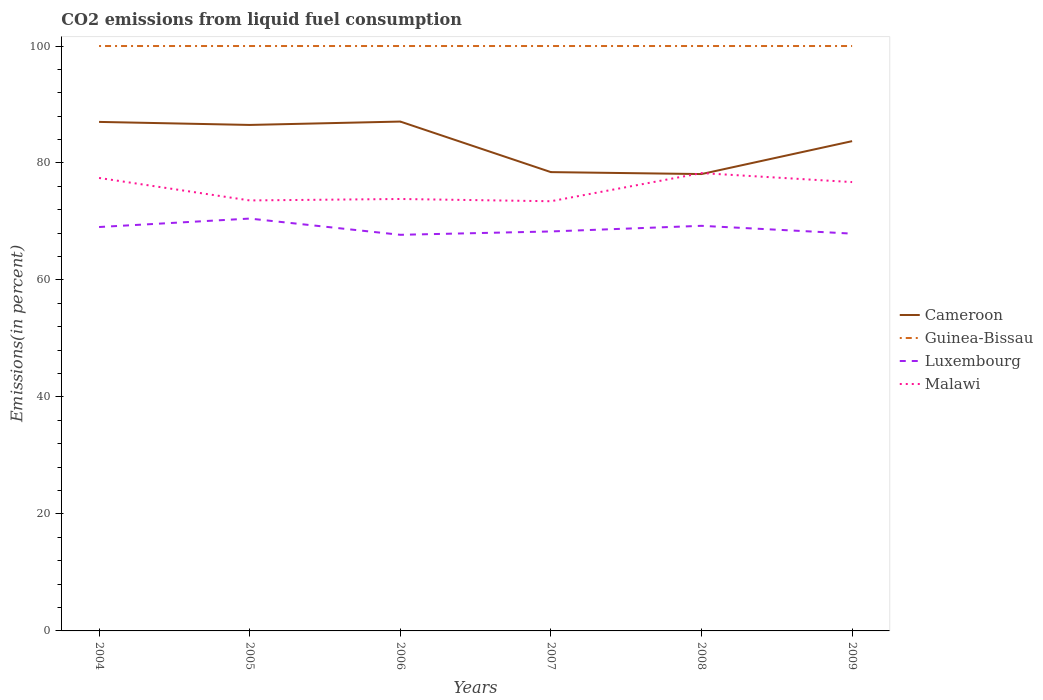Does the line corresponding to Luxembourg intersect with the line corresponding to Guinea-Bissau?
Make the answer very short. No. Across all years, what is the maximum total CO2 emitted in Malawi?
Ensure brevity in your answer.  73.46. In which year was the total CO2 emitted in Guinea-Bissau maximum?
Offer a terse response. 2004. What is the total total CO2 emitted in Guinea-Bissau in the graph?
Your answer should be very brief. 0. What is the difference between the highest and the second highest total CO2 emitted in Malawi?
Keep it short and to the point. 4.81. Is the total CO2 emitted in Guinea-Bissau strictly greater than the total CO2 emitted in Luxembourg over the years?
Provide a succinct answer. No. What is the difference between two consecutive major ticks on the Y-axis?
Give a very brief answer. 20. Are the values on the major ticks of Y-axis written in scientific E-notation?
Give a very brief answer. No. How many legend labels are there?
Your answer should be compact. 4. What is the title of the graph?
Provide a succinct answer. CO2 emissions from liquid fuel consumption. Does "Timor-Leste" appear as one of the legend labels in the graph?
Give a very brief answer. No. What is the label or title of the X-axis?
Your response must be concise. Years. What is the label or title of the Y-axis?
Ensure brevity in your answer.  Emissions(in percent). What is the Emissions(in percent) of Cameroon in 2004?
Your answer should be very brief. 87.03. What is the Emissions(in percent) of Guinea-Bissau in 2004?
Your answer should be compact. 100. What is the Emissions(in percent) of Luxembourg in 2004?
Provide a succinct answer. 69.05. What is the Emissions(in percent) in Malawi in 2004?
Provide a succinct answer. 77.44. What is the Emissions(in percent) of Cameroon in 2005?
Provide a succinct answer. 86.51. What is the Emissions(in percent) in Luxembourg in 2005?
Offer a terse response. 70.5. What is the Emissions(in percent) of Malawi in 2005?
Offer a very short reply. 73.6. What is the Emissions(in percent) in Cameroon in 2006?
Your response must be concise. 87.08. What is the Emissions(in percent) of Guinea-Bissau in 2006?
Your response must be concise. 100. What is the Emissions(in percent) of Luxembourg in 2006?
Offer a terse response. 67.72. What is the Emissions(in percent) of Malawi in 2006?
Provide a succinct answer. 73.85. What is the Emissions(in percent) of Cameroon in 2007?
Offer a very short reply. 78.44. What is the Emissions(in percent) in Luxembourg in 2007?
Offer a very short reply. 68.3. What is the Emissions(in percent) of Malawi in 2007?
Your answer should be compact. 73.46. What is the Emissions(in percent) of Cameroon in 2008?
Your answer should be compact. 78.11. What is the Emissions(in percent) of Guinea-Bissau in 2008?
Offer a very short reply. 100. What is the Emissions(in percent) of Luxembourg in 2008?
Give a very brief answer. 69.26. What is the Emissions(in percent) of Malawi in 2008?
Provide a short and direct response. 78.27. What is the Emissions(in percent) of Cameroon in 2009?
Your answer should be compact. 83.74. What is the Emissions(in percent) in Luxembourg in 2009?
Ensure brevity in your answer.  67.93. What is the Emissions(in percent) in Malawi in 2009?
Ensure brevity in your answer.  76.74. Across all years, what is the maximum Emissions(in percent) of Cameroon?
Offer a very short reply. 87.08. Across all years, what is the maximum Emissions(in percent) of Guinea-Bissau?
Make the answer very short. 100. Across all years, what is the maximum Emissions(in percent) of Luxembourg?
Provide a short and direct response. 70.5. Across all years, what is the maximum Emissions(in percent) in Malawi?
Make the answer very short. 78.27. Across all years, what is the minimum Emissions(in percent) of Cameroon?
Your answer should be very brief. 78.11. Across all years, what is the minimum Emissions(in percent) in Guinea-Bissau?
Provide a short and direct response. 100. Across all years, what is the minimum Emissions(in percent) of Luxembourg?
Give a very brief answer. 67.72. Across all years, what is the minimum Emissions(in percent) of Malawi?
Your response must be concise. 73.46. What is the total Emissions(in percent) in Cameroon in the graph?
Ensure brevity in your answer.  500.9. What is the total Emissions(in percent) of Guinea-Bissau in the graph?
Keep it short and to the point. 600. What is the total Emissions(in percent) of Luxembourg in the graph?
Provide a short and direct response. 412.75. What is the total Emissions(in percent) in Malawi in the graph?
Offer a terse response. 453.36. What is the difference between the Emissions(in percent) in Cameroon in 2004 and that in 2005?
Give a very brief answer. 0.52. What is the difference between the Emissions(in percent) in Luxembourg in 2004 and that in 2005?
Provide a succinct answer. -1.45. What is the difference between the Emissions(in percent) in Malawi in 2004 and that in 2005?
Offer a very short reply. 3.84. What is the difference between the Emissions(in percent) in Cameroon in 2004 and that in 2006?
Offer a terse response. -0.06. What is the difference between the Emissions(in percent) of Guinea-Bissau in 2004 and that in 2006?
Give a very brief answer. 0. What is the difference between the Emissions(in percent) of Luxembourg in 2004 and that in 2006?
Make the answer very short. 1.33. What is the difference between the Emissions(in percent) in Malawi in 2004 and that in 2006?
Keep it short and to the point. 3.6. What is the difference between the Emissions(in percent) of Cameroon in 2004 and that in 2007?
Offer a terse response. 8.58. What is the difference between the Emissions(in percent) of Luxembourg in 2004 and that in 2007?
Keep it short and to the point. 0.76. What is the difference between the Emissions(in percent) of Malawi in 2004 and that in 2007?
Ensure brevity in your answer.  3.98. What is the difference between the Emissions(in percent) in Cameroon in 2004 and that in 2008?
Your response must be concise. 8.92. What is the difference between the Emissions(in percent) of Guinea-Bissau in 2004 and that in 2008?
Offer a very short reply. 0. What is the difference between the Emissions(in percent) of Luxembourg in 2004 and that in 2008?
Your answer should be compact. -0.21. What is the difference between the Emissions(in percent) in Malawi in 2004 and that in 2008?
Your answer should be very brief. -0.83. What is the difference between the Emissions(in percent) of Cameroon in 2004 and that in 2009?
Keep it short and to the point. 3.29. What is the difference between the Emissions(in percent) of Luxembourg in 2004 and that in 2009?
Your answer should be very brief. 1.13. What is the difference between the Emissions(in percent) of Malawi in 2004 and that in 2009?
Give a very brief answer. 0.71. What is the difference between the Emissions(in percent) in Cameroon in 2005 and that in 2006?
Offer a very short reply. -0.58. What is the difference between the Emissions(in percent) of Luxembourg in 2005 and that in 2006?
Your response must be concise. 2.78. What is the difference between the Emissions(in percent) of Malawi in 2005 and that in 2006?
Make the answer very short. -0.25. What is the difference between the Emissions(in percent) in Cameroon in 2005 and that in 2007?
Keep it short and to the point. 8.07. What is the difference between the Emissions(in percent) in Luxembourg in 2005 and that in 2007?
Give a very brief answer. 2.2. What is the difference between the Emissions(in percent) in Malawi in 2005 and that in 2007?
Your answer should be very brief. 0.14. What is the difference between the Emissions(in percent) in Cameroon in 2005 and that in 2008?
Provide a short and direct response. 8.4. What is the difference between the Emissions(in percent) in Guinea-Bissau in 2005 and that in 2008?
Keep it short and to the point. 0. What is the difference between the Emissions(in percent) in Luxembourg in 2005 and that in 2008?
Offer a very short reply. 1.24. What is the difference between the Emissions(in percent) in Malawi in 2005 and that in 2008?
Your response must be concise. -4.67. What is the difference between the Emissions(in percent) in Cameroon in 2005 and that in 2009?
Your response must be concise. 2.77. What is the difference between the Emissions(in percent) in Luxembourg in 2005 and that in 2009?
Your answer should be very brief. 2.57. What is the difference between the Emissions(in percent) in Malawi in 2005 and that in 2009?
Your response must be concise. -3.14. What is the difference between the Emissions(in percent) in Cameroon in 2006 and that in 2007?
Offer a very short reply. 8.64. What is the difference between the Emissions(in percent) of Guinea-Bissau in 2006 and that in 2007?
Offer a very short reply. 0. What is the difference between the Emissions(in percent) in Luxembourg in 2006 and that in 2007?
Your response must be concise. -0.57. What is the difference between the Emissions(in percent) in Malawi in 2006 and that in 2007?
Give a very brief answer. 0.38. What is the difference between the Emissions(in percent) in Cameroon in 2006 and that in 2008?
Offer a terse response. 8.98. What is the difference between the Emissions(in percent) of Luxembourg in 2006 and that in 2008?
Provide a short and direct response. -1.54. What is the difference between the Emissions(in percent) of Malawi in 2006 and that in 2008?
Keep it short and to the point. -4.43. What is the difference between the Emissions(in percent) of Cameroon in 2006 and that in 2009?
Make the answer very short. 3.35. What is the difference between the Emissions(in percent) of Guinea-Bissau in 2006 and that in 2009?
Your response must be concise. 0. What is the difference between the Emissions(in percent) of Luxembourg in 2006 and that in 2009?
Ensure brevity in your answer.  -0.2. What is the difference between the Emissions(in percent) in Malawi in 2006 and that in 2009?
Your response must be concise. -2.89. What is the difference between the Emissions(in percent) of Cameroon in 2007 and that in 2008?
Keep it short and to the point. 0.33. What is the difference between the Emissions(in percent) in Guinea-Bissau in 2007 and that in 2008?
Offer a terse response. 0. What is the difference between the Emissions(in percent) in Luxembourg in 2007 and that in 2008?
Give a very brief answer. -0.96. What is the difference between the Emissions(in percent) in Malawi in 2007 and that in 2008?
Offer a terse response. -4.81. What is the difference between the Emissions(in percent) in Cameroon in 2007 and that in 2009?
Offer a terse response. -5.29. What is the difference between the Emissions(in percent) in Guinea-Bissau in 2007 and that in 2009?
Your answer should be very brief. 0. What is the difference between the Emissions(in percent) of Luxembourg in 2007 and that in 2009?
Offer a terse response. 0.37. What is the difference between the Emissions(in percent) of Malawi in 2007 and that in 2009?
Offer a very short reply. -3.27. What is the difference between the Emissions(in percent) in Cameroon in 2008 and that in 2009?
Provide a succinct answer. -5.63. What is the difference between the Emissions(in percent) in Luxembourg in 2008 and that in 2009?
Offer a very short reply. 1.33. What is the difference between the Emissions(in percent) in Malawi in 2008 and that in 2009?
Your answer should be compact. 1.54. What is the difference between the Emissions(in percent) of Cameroon in 2004 and the Emissions(in percent) of Guinea-Bissau in 2005?
Make the answer very short. -12.97. What is the difference between the Emissions(in percent) in Cameroon in 2004 and the Emissions(in percent) in Luxembourg in 2005?
Your answer should be very brief. 16.53. What is the difference between the Emissions(in percent) of Cameroon in 2004 and the Emissions(in percent) of Malawi in 2005?
Make the answer very short. 13.43. What is the difference between the Emissions(in percent) in Guinea-Bissau in 2004 and the Emissions(in percent) in Luxembourg in 2005?
Keep it short and to the point. 29.5. What is the difference between the Emissions(in percent) in Guinea-Bissau in 2004 and the Emissions(in percent) in Malawi in 2005?
Your response must be concise. 26.4. What is the difference between the Emissions(in percent) in Luxembourg in 2004 and the Emissions(in percent) in Malawi in 2005?
Offer a very short reply. -4.55. What is the difference between the Emissions(in percent) of Cameroon in 2004 and the Emissions(in percent) of Guinea-Bissau in 2006?
Offer a terse response. -12.97. What is the difference between the Emissions(in percent) of Cameroon in 2004 and the Emissions(in percent) of Luxembourg in 2006?
Provide a short and direct response. 19.3. What is the difference between the Emissions(in percent) of Cameroon in 2004 and the Emissions(in percent) of Malawi in 2006?
Provide a short and direct response. 13.18. What is the difference between the Emissions(in percent) in Guinea-Bissau in 2004 and the Emissions(in percent) in Luxembourg in 2006?
Offer a terse response. 32.28. What is the difference between the Emissions(in percent) in Guinea-Bissau in 2004 and the Emissions(in percent) in Malawi in 2006?
Provide a short and direct response. 26.15. What is the difference between the Emissions(in percent) of Luxembourg in 2004 and the Emissions(in percent) of Malawi in 2006?
Give a very brief answer. -4.79. What is the difference between the Emissions(in percent) in Cameroon in 2004 and the Emissions(in percent) in Guinea-Bissau in 2007?
Provide a succinct answer. -12.97. What is the difference between the Emissions(in percent) in Cameroon in 2004 and the Emissions(in percent) in Luxembourg in 2007?
Your answer should be very brief. 18.73. What is the difference between the Emissions(in percent) in Cameroon in 2004 and the Emissions(in percent) in Malawi in 2007?
Make the answer very short. 13.56. What is the difference between the Emissions(in percent) in Guinea-Bissau in 2004 and the Emissions(in percent) in Luxembourg in 2007?
Offer a very short reply. 31.7. What is the difference between the Emissions(in percent) of Guinea-Bissau in 2004 and the Emissions(in percent) of Malawi in 2007?
Offer a very short reply. 26.54. What is the difference between the Emissions(in percent) in Luxembourg in 2004 and the Emissions(in percent) in Malawi in 2007?
Keep it short and to the point. -4.41. What is the difference between the Emissions(in percent) of Cameroon in 2004 and the Emissions(in percent) of Guinea-Bissau in 2008?
Give a very brief answer. -12.97. What is the difference between the Emissions(in percent) in Cameroon in 2004 and the Emissions(in percent) in Luxembourg in 2008?
Give a very brief answer. 17.77. What is the difference between the Emissions(in percent) of Cameroon in 2004 and the Emissions(in percent) of Malawi in 2008?
Ensure brevity in your answer.  8.75. What is the difference between the Emissions(in percent) in Guinea-Bissau in 2004 and the Emissions(in percent) in Luxembourg in 2008?
Your answer should be compact. 30.74. What is the difference between the Emissions(in percent) in Guinea-Bissau in 2004 and the Emissions(in percent) in Malawi in 2008?
Give a very brief answer. 21.73. What is the difference between the Emissions(in percent) in Luxembourg in 2004 and the Emissions(in percent) in Malawi in 2008?
Make the answer very short. -9.22. What is the difference between the Emissions(in percent) in Cameroon in 2004 and the Emissions(in percent) in Guinea-Bissau in 2009?
Offer a very short reply. -12.97. What is the difference between the Emissions(in percent) in Cameroon in 2004 and the Emissions(in percent) in Luxembourg in 2009?
Offer a very short reply. 19.1. What is the difference between the Emissions(in percent) of Cameroon in 2004 and the Emissions(in percent) of Malawi in 2009?
Your response must be concise. 10.29. What is the difference between the Emissions(in percent) in Guinea-Bissau in 2004 and the Emissions(in percent) in Luxembourg in 2009?
Provide a short and direct response. 32.07. What is the difference between the Emissions(in percent) of Guinea-Bissau in 2004 and the Emissions(in percent) of Malawi in 2009?
Make the answer very short. 23.26. What is the difference between the Emissions(in percent) of Luxembourg in 2004 and the Emissions(in percent) of Malawi in 2009?
Give a very brief answer. -7.68. What is the difference between the Emissions(in percent) in Cameroon in 2005 and the Emissions(in percent) in Guinea-Bissau in 2006?
Your answer should be very brief. -13.49. What is the difference between the Emissions(in percent) in Cameroon in 2005 and the Emissions(in percent) in Luxembourg in 2006?
Make the answer very short. 18.79. What is the difference between the Emissions(in percent) in Cameroon in 2005 and the Emissions(in percent) in Malawi in 2006?
Give a very brief answer. 12.66. What is the difference between the Emissions(in percent) in Guinea-Bissau in 2005 and the Emissions(in percent) in Luxembourg in 2006?
Provide a short and direct response. 32.28. What is the difference between the Emissions(in percent) of Guinea-Bissau in 2005 and the Emissions(in percent) of Malawi in 2006?
Your answer should be compact. 26.15. What is the difference between the Emissions(in percent) in Luxembourg in 2005 and the Emissions(in percent) in Malawi in 2006?
Give a very brief answer. -3.35. What is the difference between the Emissions(in percent) in Cameroon in 2005 and the Emissions(in percent) in Guinea-Bissau in 2007?
Give a very brief answer. -13.49. What is the difference between the Emissions(in percent) in Cameroon in 2005 and the Emissions(in percent) in Luxembourg in 2007?
Provide a short and direct response. 18.21. What is the difference between the Emissions(in percent) in Cameroon in 2005 and the Emissions(in percent) in Malawi in 2007?
Provide a succinct answer. 13.05. What is the difference between the Emissions(in percent) of Guinea-Bissau in 2005 and the Emissions(in percent) of Luxembourg in 2007?
Give a very brief answer. 31.7. What is the difference between the Emissions(in percent) in Guinea-Bissau in 2005 and the Emissions(in percent) in Malawi in 2007?
Your answer should be very brief. 26.54. What is the difference between the Emissions(in percent) in Luxembourg in 2005 and the Emissions(in percent) in Malawi in 2007?
Provide a succinct answer. -2.96. What is the difference between the Emissions(in percent) of Cameroon in 2005 and the Emissions(in percent) of Guinea-Bissau in 2008?
Your answer should be very brief. -13.49. What is the difference between the Emissions(in percent) of Cameroon in 2005 and the Emissions(in percent) of Luxembourg in 2008?
Ensure brevity in your answer.  17.25. What is the difference between the Emissions(in percent) of Cameroon in 2005 and the Emissions(in percent) of Malawi in 2008?
Offer a very short reply. 8.23. What is the difference between the Emissions(in percent) of Guinea-Bissau in 2005 and the Emissions(in percent) of Luxembourg in 2008?
Provide a short and direct response. 30.74. What is the difference between the Emissions(in percent) of Guinea-Bissau in 2005 and the Emissions(in percent) of Malawi in 2008?
Give a very brief answer. 21.73. What is the difference between the Emissions(in percent) in Luxembourg in 2005 and the Emissions(in percent) in Malawi in 2008?
Make the answer very short. -7.78. What is the difference between the Emissions(in percent) of Cameroon in 2005 and the Emissions(in percent) of Guinea-Bissau in 2009?
Your answer should be compact. -13.49. What is the difference between the Emissions(in percent) of Cameroon in 2005 and the Emissions(in percent) of Luxembourg in 2009?
Keep it short and to the point. 18.58. What is the difference between the Emissions(in percent) of Cameroon in 2005 and the Emissions(in percent) of Malawi in 2009?
Keep it short and to the point. 9.77. What is the difference between the Emissions(in percent) in Guinea-Bissau in 2005 and the Emissions(in percent) in Luxembourg in 2009?
Your answer should be very brief. 32.07. What is the difference between the Emissions(in percent) of Guinea-Bissau in 2005 and the Emissions(in percent) of Malawi in 2009?
Offer a very short reply. 23.26. What is the difference between the Emissions(in percent) in Luxembourg in 2005 and the Emissions(in percent) in Malawi in 2009?
Your answer should be very brief. -6.24. What is the difference between the Emissions(in percent) in Cameroon in 2006 and the Emissions(in percent) in Guinea-Bissau in 2007?
Your answer should be compact. -12.92. What is the difference between the Emissions(in percent) in Cameroon in 2006 and the Emissions(in percent) in Luxembourg in 2007?
Your answer should be very brief. 18.79. What is the difference between the Emissions(in percent) in Cameroon in 2006 and the Emissions(in percent) in Malawi in 2007?
Offer a terse response. 13.62. What is the difference between the Emissions(in percent) in Guinea-Bissau in 2006 and the Emissions(in percent) in Luxembourg in 2007?
Make the answer very short. 31.7. What is the difference between the Emissions(in percent) in Guinea-Bissau in 2006 and the Emissions(in percent) in Malawi in 2007?
Offer a terse response. 26.54. What is the difference between the Emissions(in percent) of Luxembourg in 2006 and the Emissions(in percent) of Malawi in 2007?
Offer a terse response. -5.74. What is the difference between the Emissions(in percent) in Cameroon in 2006 and the Emissions(in percent) in Guinea-Bissau in 2008?
Provide a short and direct response. -12.92. What is the difference between the Emissions(in percent) of Cameroon in 2006 and the Emissions(in percent) of Luxembourg in 2008?
Your response must be concise. 17.83. What is the difference between the Emissions(in percent) in Cameroon in 2006 and the Emissions(in percent) in Malawi in 2008?
Your response must be concise. 8.81. What is the difference between the Emissions(in percent) of Guinea-Bissau in 2006 and the Emissions(in percent) of Luxembourg in 2008?
Provide a short and direct response. 30.74. What is the difference between the Emissions(in percent) in Guinea-Bissau in 2006 and the Emissions(in percent) in Malawi in 2008?
Offer a terse response. 21.73. What is the difference between the Emissions(in percent) of Luxembourg in 2006 and the Emissions(in percent) of Malawi in 2008?
Provide a succinct answer. -10.55. What is the difference between the Emissions(in percent) in Cameroon in 2006 and the Emissions(in percent) in Guinea-Bissau in 2009?
Offer a terse response. -12.92. What is the difference between the Emissions(in percent) of Cameroon in 2006 and the Emissions(in percent) of Luxembourg in 2009?
Provide a short and direct response. 19.16. What is the difference between the Emissions(in percent) in Cameroon in 2006 and the Emissions(in percent) in Malawi in 2009?
Give a very brief answer. 10.35. What is the difference between the Emissions(in percent) in Guinea-Bissau in 2006 and the Emissions(in percent) in Luxembourg in 2009?
Ensure brevity in your answer.  32.07. What is the difference between the Emissions(in percent) of Guinea-Bissau in 2006 and the Emissions(in percent) of Malawi in 2009?
Provide a succinct answer. 23.26. What is the difference between the Emissions(in percent) in Luxembourg in 2006 and the Emissions(in percent) in Malawi in 2009?
Give a very brief answer. -9.01. What is the difference between the Emissions(in percent) of Cameroon in 2007 and the Emissions(in percent) of Guinea-Bissau in 2008?
Offer a terse response. -21.56. What is the difference between the Emissions(in percent) of Cameroon in 2007 and the Emissions(in percent) of Luxembourg in 2008?
Provide a succinct answer. 9.18. What is the difference between the Emissions(in percent) in Cameroon in 2007 and the Emissions(in percent) in Malawi in 2008?
Provide a succinct answer. 0.17. What is the difference between the Emissions(in percent) in Guinea-Bissau in 2007 and the Emissions(in percent) in Luxembourg in 2008?
Your response must be concise. 30.74. What is the difference between the Emissions(in percent) of Guinea-Bissau in 2007 and the Emissions(in percent) of Malawi in 2008?
Your answer should be compact. 21.73. What is the difference between the Emissions(in percent) in Luxembourg in 2007 and the Emissions(in percent) in Malawi in 2008?
Offer a terse response. -9.98. What is the difference between the Emissions(in percent) of Cameroon in 2007 and the Emissions(in percent) of Guinea-Bissau in 2009?
Provide a short and direct response. -21.56. What is the difference between the Emissions(in percent) of Cameroon in 2007 and the Emissions(in percent) of Luxembourg in 2009?
Provide a short and direct response. 10.52. What is the difference between the Emissions(in percent) of Cameroon in 2007 and the Emissions(in percent) of Malawi in 2009?
Provide a succinct answer. 1.71. What is the difference between the Emissions(in percent) in Guinea-Bissau in 2007 and the Emissions(in percent) in Luxembourg in 2009?
Ensure brevity in your answer.  32.07. What is the difference between the Emissions(in percent) of Guinea-Bissau in 2007 and the Emissions(in percent) of Malawi in 2009?
Provide a short and direct response. 23.26. What is the difference between the Emissions(in percent) in Luxembourg in 2007 and the Emissions(in percent) in Malawi in 2009?
Give a very brief answer. -8.44. What is the difference between the Emissions(in percent) in Cameroon in 2008 and the Emissions(in percent) in Guinea-Bissau in 2009?
Offer a terse response. -21.89. What is the difference between the Emissions(in percent) of Cameroon in 2008 and the Emissions(in percent) of Luxembourg in 2009?
Keep it short and to the point. 10.18. What is the difference between the Emissions(in percent) of Cameroon in 2008 and the Emissions(in percent) of Malawi in 2009?
Provide a succinct answer. 1.37. What is the difference between the Emissions(in percent) of Guinea-Bissau in 2008 and the Emissions(in percent) of Luxembourg in 2009?
Offer a terse response. 32.07. What is the difference between the Emissions(in percent) of Guinea-Bissau in 2008 and the Emissions(in percent) of Malawi in 2009?
Your answer should be very brief. 23.26. What is the difference between the Emissions(in percent) in Luxembourg in 2008 and the Emissions(in percent) in Malawi in 2009?
Keep it short and to the point. -7.48. What is the average Emissions(in percent) in Cameroon per year?
Make the answer very short. 83.48. What is the average Emissions(in percent) in Guinea-Bissau per year?
Provide a short and direct response. 100. What is the average Emissions(in percent) of Luxembourg per year?
Provide a succinct answer. 68.79. What is the average Emissions(in percent) of Malawi per year?
Keep it short and to the point. 75.56. In the year 2004, what is the difference between the Emissions(in percent) of Cameroon and Emissions(in percent) of Guinea-Bissau?
Ensure brevity in your answer.  -12.97. In the year 2004, what is the difference between the Emissions(in percent) of Cameroon and Emissions(in percent) of Luxembourg?
Give a very brief answer. 17.97. In the year 2004, what is the difference between the Emissions(in percent) in Cameroon and Emissions(in percent) in Malawi?
Provide a short and direct response. 9.58. In the year 2004, what is the difference between the Emissions(in percent) in Guinea-Bissau and Emissions(in percent) in Luxembourg?
Your answer should be very brief. 30.95. In the year 2004, what is the difference between the Emissions(in percent) of Guinea-Bissau and Emissions(in percent) of Malawi?
Provide a succinct answer. 22.56. In the year 2004, what is the difference between the Emissions(in percent) of Luxembourg and Emissions(in percent) of Malawi?
Your answer should be very brief. -8.39. In the year 2005, what is the difference between the Emissions(in percent) of Cameroon and Emissions(in percent) of Guinea-Bissau?
Keep it short and to the point. -13.49. In the year 2005, what is the difference between the Emissions(in percent) of Cameroon and Emissions(in percent) of Luxembourg?
Give a very brief answer. 16.01. In the year 2005, what is the difference between the Emissions(in percent) in Cameroon and Emissions(in percent) in Malawi?
Keep it short and to the point. 12.91. In the year 2005, what is the difference between the Emissions(in percent) of Guinea-Bissau and Emissions(in percent) of Luxembourg?
Provide a short and direct response. 29.5. In the year 2005, what is the difference between the Emissions(in percent) of Guinea-Bissau and Emissions(in percent) of Malawi?
Make the answer very short. 26.4. In the year 2005, what is the difference between the Emissions(in percent) of Luxembourg and Emissions(in percent) of Malawi?
Your answer should be compact. -3.1. In the year 2006, what is the difference between the Emissions(in percent) of Cameroon and Emissions(in percent) of Guinea-Bissau?
Your response must be concise. -12.92. In the year 2006, what is the difference between the Emissions(in percent) in Cameroon and Emissions(in percent) in Luxembourg?
Your response must be concise. 19.36. In the year 2006, what is the difference between the Emissions(in percent) of Cameroon and Emissions(in percent) of Malawi?
Ensure brevity in your answer.  13.24. In the year 2006, what is the difference between the Emissions(in percent) in Guinea-Bissau and Emissions(in percent) in Luxembourg?
Keep it short and to the point. 32.28. In the year 2006, what is the difference between the Emissions(in percent) in Guinea-Bissau and Emissions(in percent) in Malawi?
Your answer should be very brief. 26.15. In the year 2006, what is the difference between the Emissions(in percent) in Luxembourg and Emissions(in percent) in Malawi?
Your answer should be very brief. -6.12. In the year 2007, what is the difference between the Emissions(in percent) of Cameroon and Emissions(in percent) of Guinea-Bissau?
Your answer should be very brief. -21.56. In the year 2007, what is the difference between the Emissions(in percent) in Cameroon and Emissions(in percent) in Luxembourg?
Your answer should be compact. 10.14. In the year 2007, what is the difference between the Emissions(in percent) of Cameroon and Emissions(in percent) of Malawi?
Offer a terse response. 4.98. In the year 2007, what is the difference between the Emissions(in percent) of Guinea-Bissau and Emissions(in percent) of Luxembourg?
Provide a succinct answer. 31.7. In the year 2007, what is the difference between the Emissions(in percent) in Guinea-Bissau and Emissions(in percent) in Malawi?
Provide a short and direct response. 26.54. In the year 2007, what is the difference between the Emissions(in percent) of Luxembourg and Emissions(in percent) of Malawi?
Offer a terse response. -5.16. In the year 2008, what is the difference between the Emissions(in percent) of Cameroon and Emissions(in percent) of Guinea-Bissau?
Offer a terse response. -21.89. In the year 2008, what is the difference between the Emissions(in percent) of Cameroon and Emissions(in percent) of Luxembourg?
Ensure brevity in your answer.  8.85. In the year 2008, what is the difference between the Emissions(in percent) in Cameroon and Emissions(in percent) in Malawi?
Provide a short and direct response. -0.17. In the year 2008, what is the difference between the Emissions(in percent) of Guinea-Bissau and Emissions(in percent) of Luxembourg?
Your answer should be very brief. 30.74. In the year 2008, what is the difference between the Emissions(in percent) of Guinea-Bissau and Emissions(in percent) of Malawi?
Your response must be concise. 21.73. In the year 2008, what is the difference between the Emissions(in percent) in Luxembourg and Emissions(in percent) in Malawi?
Offer a very short reply. -9.02. In the year 2009, what is the difference between the Emissions(in percent) in Cameroon and Emissions(in percent) in Guinea-Bissau?
Provide a short and direct response. -16.26. In the year 2009, what is the difference between the Emissions(in percent) of Cameroon and Emissions(in percent) of Luxembourg?
Give a very brief answer. 15.81. In the year 2009, what is the difference between the Emissions(in percent) of Cameroon and Emissions(in percent) of Malawi?
Offer a very short reply. 7. In the year 2009, what is the difference between the Emissions(in percent) of Guinea-Bissau and Emissions(in percent) of Luxembourg?
Make the answer very short. 32.07. In the year 2009, what is the difference between the Emissions(in percent) in Guinea-Bissau and Emissions(in percent) in Malawi?
Ensure brevity in your answer.  23.26. In the year 2009, what is the difference between the Emissions(in percent) of Luxembourg and Emissions(in percent) of Malawi?
Your answer should be very brief. -8.81. What is the ratio of the Emissions(in percent) in Cameroon in 2004 to that in 2005?
Provide a short and direct response. 1.01. What is the ratio of the Emissions(in percent) in Luxembourg in 2004 to that in 2005?
Your answer should be compact. 0.98. What is the ratio of the Emissions(in percent) in Malawi in 2004 to that in 2005?
Your answer should be compact. 1.05. What is the ratio of the Emissions(in percent) in Guinea-Bissau in 2004 to that in 2006?
Provide a short and direct response. 1. What is the ratio of the Emissions(in percent) in Luxembourg in 2004 to that in 2006?
Keep it short and to the point. 1.02. What is the ratio of the Emissions(in percent) of Malawi in 2004 to that in 2006?
Your response must be concise. 1.05. What is the ratio of the Emissions(in percent) in Cameroon in 2004 to that in 2007?
Provide a succinct answer. 1.11. What is the ratio of the Emissions(in percent) in Luxembourg in 2004 to that in 2007?
Offer a terse response. 1.01. What is the ratio of the Emissions(in percent) of Malawi in 2004 to that in 2007?
Your answer should be compact. 1.05. What is the ratio of the Emissions(in percent) in Cameroon in 2004 to that in 2008?
Your answer should be compact. 1.11. What is the ratio of the Emissions(in percent) of Guinea-Bissau in 2004 to that in 2008?
Keep it short and to the point. 1. What is the ratio of the Emissions(in percent) in Cameroon in 2004 to that in 2009?
Your answer should be compact. 1.04. What is the ratio of the Emissions(in percent) of Luxembourg in 2004 to that in 2009?
Offer a very short reply. 1.02. What is the ratio of the Emissions(in percent) of Malawi in 2004 to that in 2009?
Make the answer very short. 1.01. What is the ratio of the Emissions(in percent) of Luxembourg in 2005 to that in 2006?
Keep it short and to the point. 1.04. What is the ratio of the Emissions(in percent) of Cameroon in 2005 to that in 2007?
Your response must be concise. 1.1. What is the ratio of the Emissions(in percent) in Luxembourg in 2005 to that in 2007?
Provide a succinct answer. 1.03. What is the ratio of the Emissions(in percent) in Malawi in 2005 to that in 2007?
Your response must be concise. 1. What is the ratio of the Emissions(in percent) of Cameroon in 2005 to that in 2008?
Your answer should be very brief. 1.11. What is the ratio of the Emissions(in percent) of Guinea-Bissau in 2005 to that in 2008?
Ensure brevity in your answer.  1. What is the ratio of the Emissions(in percent) in Luxembourg in 2005 to that in 2008?
Keep it short and to the point. 1.02. What is the ratio of the Emissions(in percent) in Malawi in 2005 to that in 2008?
Your answer should be compact. 0.94. What is the ratio of the Emissions(in percent) of Cameroon in 2005 to that in 2009?
Your response must be concise. 1.03. What is the ratio of the Emissions(in percent) in Luxembourg in 2005 to that in 2009?
Your answer should be compact. 1.04. What is the ratio of the Emissions(in percent) in Malawi in 2005 to that in 2009?
Make the answer very short. 0.96. What is the ratio of the Emissions(in percent) in Cameroon in 2006 to that in 2007?
Offer a very short reply. 1.11. What is the ratio of the Emissions(in percent) in Guinea-Bissau in 2006 to that in 2007?
Ensure brevity in your answer.  1. What is the ratio of the Emissions(in percent) in Luxembourg in 2006 to that in 2007?
Your response must be concise. 0.99. What is the ratio of the Emissions(in percent) in Cameroon in 2006 to that in 2008?
Provide a short and direct response. 1.11. What is the ratio of the Emissions(in percent) of Guinea-Bissau in 2006 to that in 2008?
Offer a very short reply. 1. What is the ratio of the Emissions(in percent) in Luxembourg in 2006 to that in 2008?
Provide a short and direct response. 0.98. What is the ratio of the Emissions(in percent) of Malawi in 2006 to that in 2008?
Provide a succinct answer. 0.94. What is the ratio of the Emissions(in percent) of Cameroon in 2006 to that in 2009?
Your response must be concise. 1.04. What is the ratio of the Emissions(in percent) of Guinea-Bissau in 2006 to that in 2009?
Keep it short and to the point. 1. What is the ratio of the Emissions(in percent) in Malawi in 2006 to that in 2009?
Your answer should be compact. 0.96. What is the ratio of the Emissions(in percent) in Cameroon in 2007 to that in 2008?
Give a very brief answer. 1. What is the ratio of the Emissions(in percent) in Guinea-Bissau in 2007 to that in 2008?
Provide a succinct answer. 1. What is the ratio of the Emissions(in percent) in Luxembourg in 2007 to that in 2008?
Give a very brief answer. 0.99. What is the ratio of the Emissions(in percent) in Malawi in 2007 to that in 2008?
Offer a terse response. 0.94. What is the ratio of the Emissions(in percent) of Cameroon in 2007 to that in 2009?
Your answer should be very brief. 0.94. What is the ratio of the Emissions(in percent) of Malawi in 2007 to that in 2009?
Offer a very short reply. 0.96. What is the ratio of the Emissions(in percent) of Cameroon in 2008 to that in 2009?
Give a very brief answer. 0.93. What is the ratio of the Emissions(in percent) in Luxembourg in 2008 to that in 2009?
Make the answer very short. 1.02. What is the ratio of the Emissions(in percent) of Malawi in 2008 to that in 2009?
Your answer should be very brief. 1.02. What is the difference between the highest and the second highest Emissions(in percent) of Cameroon?
Offer a terse response. 0.06. What is the difference between the highest and the second highest Emissions(in percent) of Luxembourg?
Ensure brevity in your answer.  1.24. What is the difference between the highest and the second highest Emissions(in percent) in Malawi?
Make the answer very short. 0.83. What is the difference between the highest and the lowest Emissions(in percent) in Cameroon?
Keep it short and to the point. 8.98. What is the difference between the highest and the lowest Emissions(in percent) in Luxembourg?
Keep it short and to the point. 2.78. What is the difference between the highest and the lowest Emissions(in percent) of Malawi?
Make the answer very short. 4.81. 